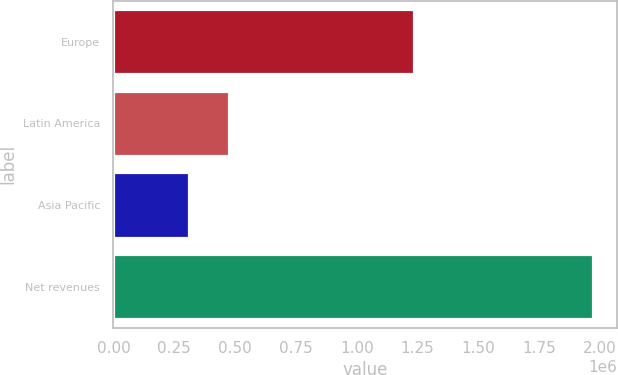Convert chart. <chart><loc_0><loc_0><loc_500><loc_500><bar_chart><fcel>Europe<fcel>Latin America<fcel>Asia Pacific<fcel>Net revenues<nl><fcel>1.23685e+06<fcel>475216<fcel>308920<fcel>1.97188e+06<nl></chart> 